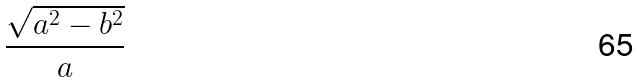<formula> <loc_0><loc_0><loc_500><loc_500>\frac { \sqrt { a ^ { 2 } - b ^ { 2 } } } { a }</formula> 